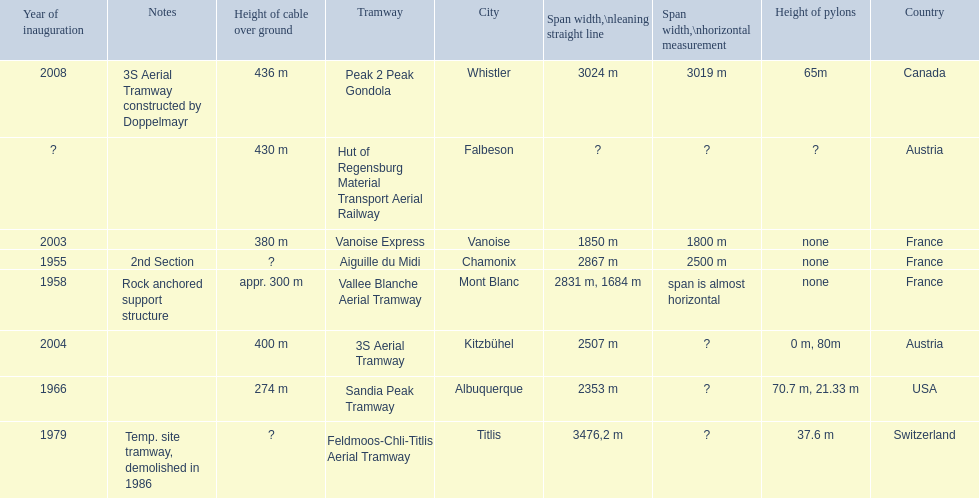Which tramway was built directly before the 3s aeriral tramway? Vanoise Express. 